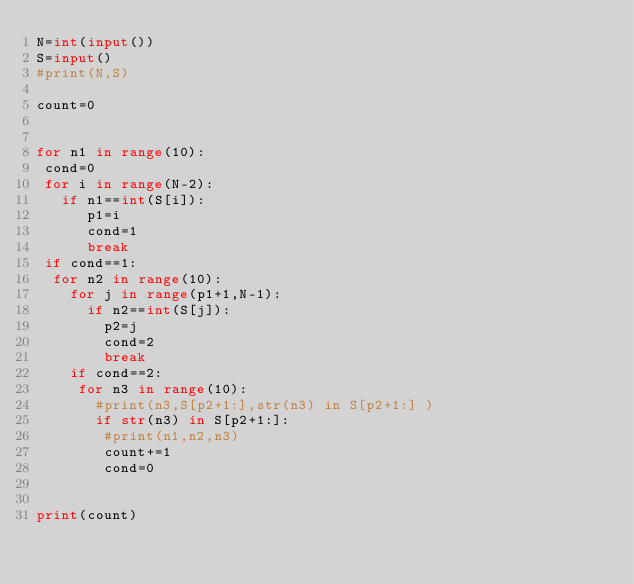<code> <loc_0><loc_0><loc_500><loc_500><_Python_>N=int(input())
S=input()
#print(N,S)

count=0


for n1 in range(10):
 cond=0
 for i in range(N-2):
   if n1==int(S[i]):
      p1=i
      cond=1
      break
 if cond==1:
  for n2 in range(10):
    for j in range(p1+1,N-1):
      if n2==int(S[j]):
        p2=j
        cond=2
        break
    if cond==2:
     for n3 in range(10):
       #print(n3,S[p2+1:],str(n3) in S[p2+1:] )
       if str(n3) in S[p2+1:]:
        #print(n1,n2,n3)
        count+=1
        cond=0
      
              
print(count)
</code> 